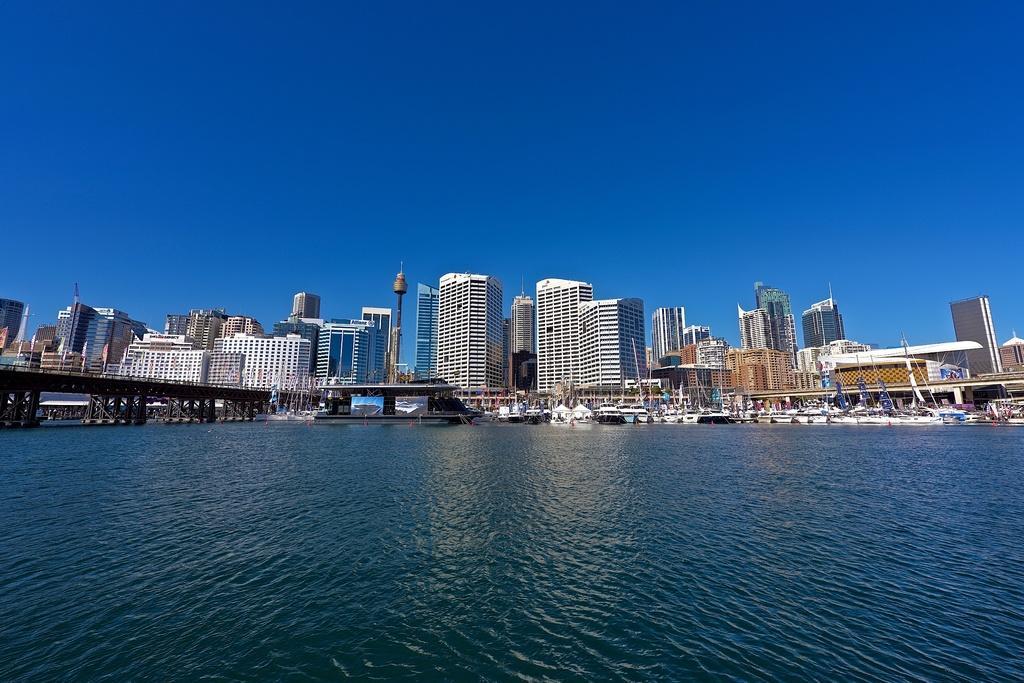Can you describe this image briefly? In this image I can see the water, a bridge and few boats which are white in color on the surface of the water. In the background I can see few buildings and the sky. 